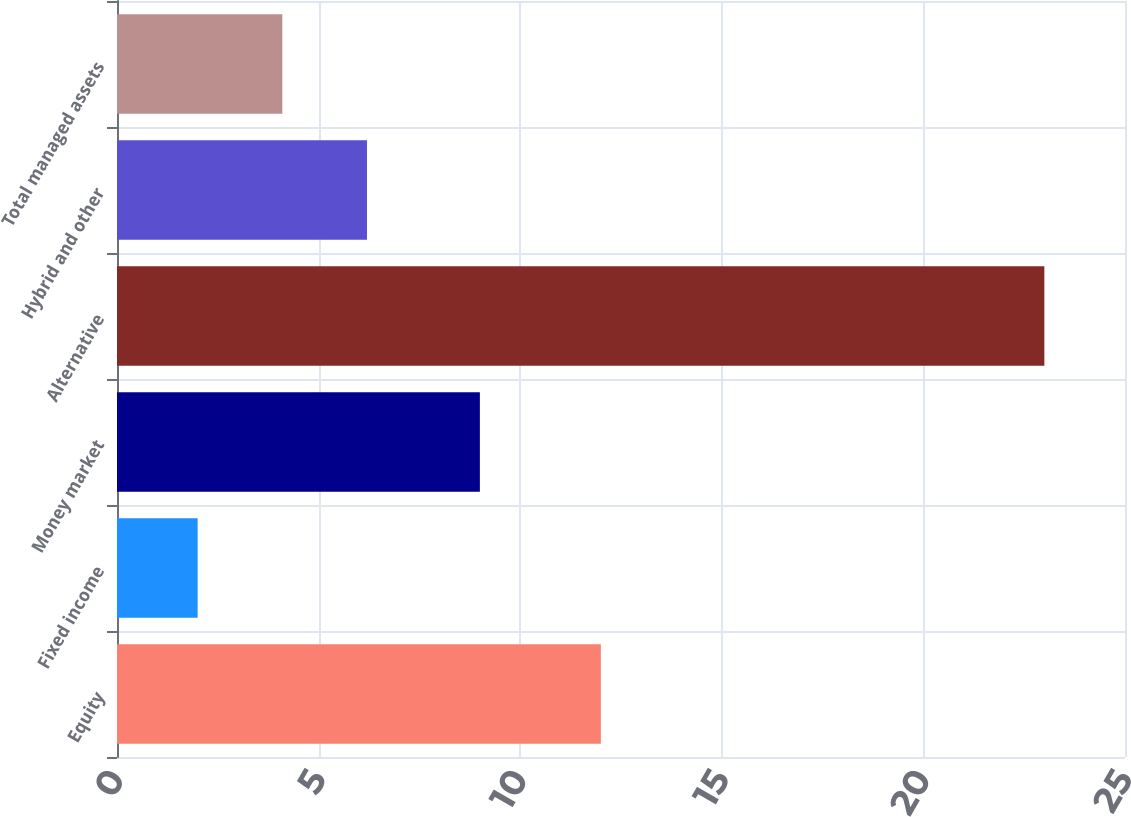Convert chart to OTSL. <chart><loc_0><loc_0><loc_500><loc_500><bar_chart><fcel>Equity<fcel>Fixed income<fcel>Money market<fcel>Alternative<fcel>Hybrid and other<fcel>Total managed assets<nl><fcel>12<fcel>2<fcel>9<fcel>23<fcel>6.2<fcel>4.1<nl></chart> 